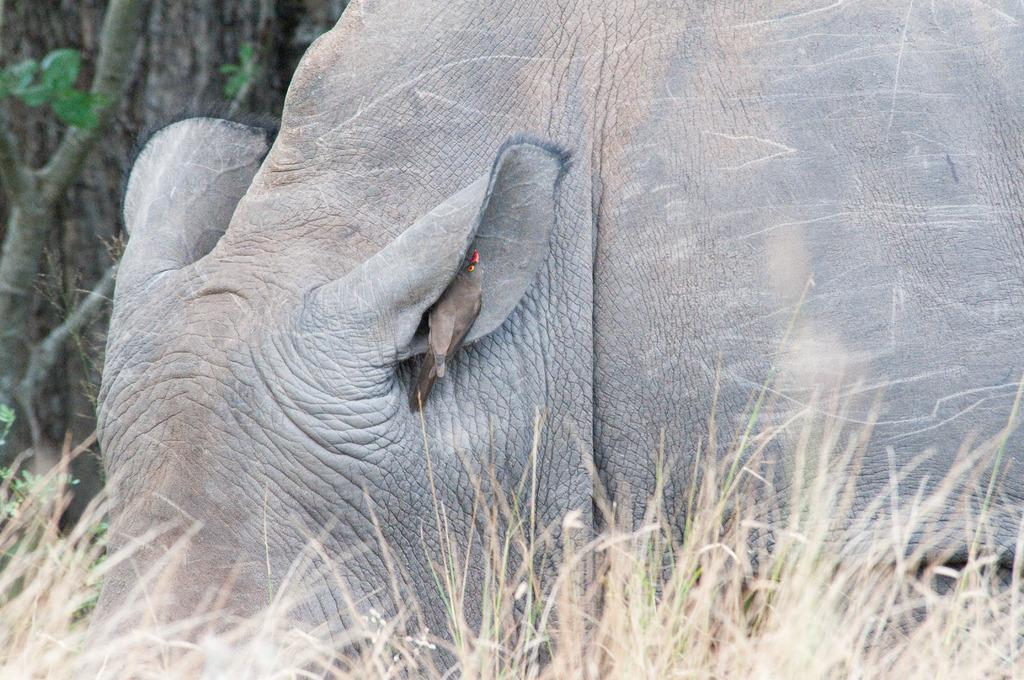What type of animal is present in the image? The animal is not fully visible in the image, but it is the one the bird is on. What is the bird doing in the image? The bird is perched on the animal. What type of environment is depicted in the image? The image shows grass at the bottom, which suggests an outdoor setting. What other natural elements can be seen in the image? Leaves are present in the image. What is the bird's hearing like in the image? There is no information about the bird's hearing in the image. Can you tell me how many circles are visible in the image? There are no circles present in the image. 